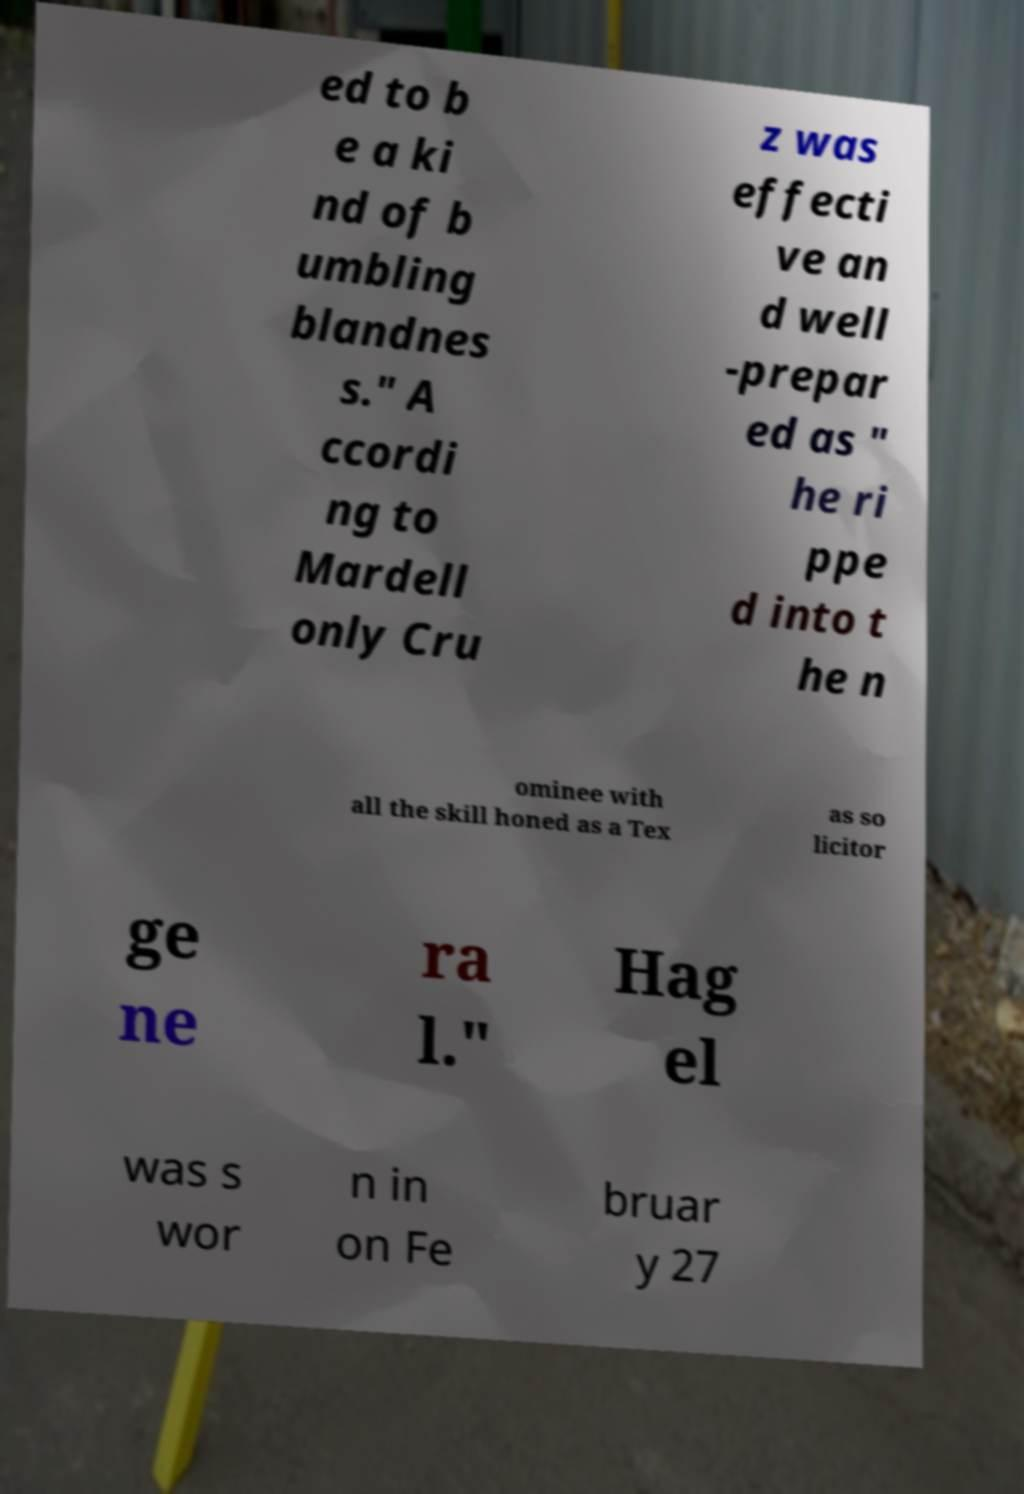There's text embedded in this image that I need extracted. Can you transcribe it verbatim? ed to b e a ki nd of b umbling blandnes s." A ccordi ng to Mardell only Cru z was effecti ve an d well -prepar ed as " he ri ppe d into t he n ominee with all the skill honed as a Tex as so licitor ge ne ra l." Hag el was s wor n in on Fe bruar y 27 